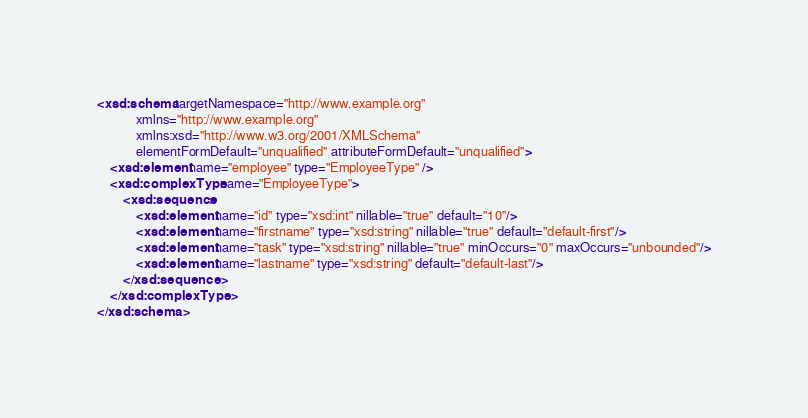Convert code to text. <code><loc_0><loc_0><loc_500><loc_500><_XML_><xsd:schema targetNamespace="http://www.example.org"
            xmlns="http://www.example.org"
            xmlns:xsd="http://www.w3.org/2001/XMLSchema"
            elementFormDefault="unqualified" attributeFormDefault="unqualified">
    <xsd:element name="employee" type="EmployeeType" />
    <xsd:complexType name="EmployeeType">
        <xsd:sequence>
            <xsd:element name="id" type="xsd:int" nillable="true" default="10"/>
            <xsd:element name="firstname" type="xsd:string" nillable="true" default="default-first"/>
            <xsd:element name="task" type="xsd:string" nillable="true" minOccurs="0" maxOccurs="unbounded"/>
            <xsd:element name="lastname" type="xsd:string" default="default-last"/>
        </xsd:sequence>
    </xsd:complexType>
</xsd:schema>
</code> 